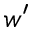<formula> <loc_0><loc_0><loc_500><loc_500>w ^ { \prime }</formula> 